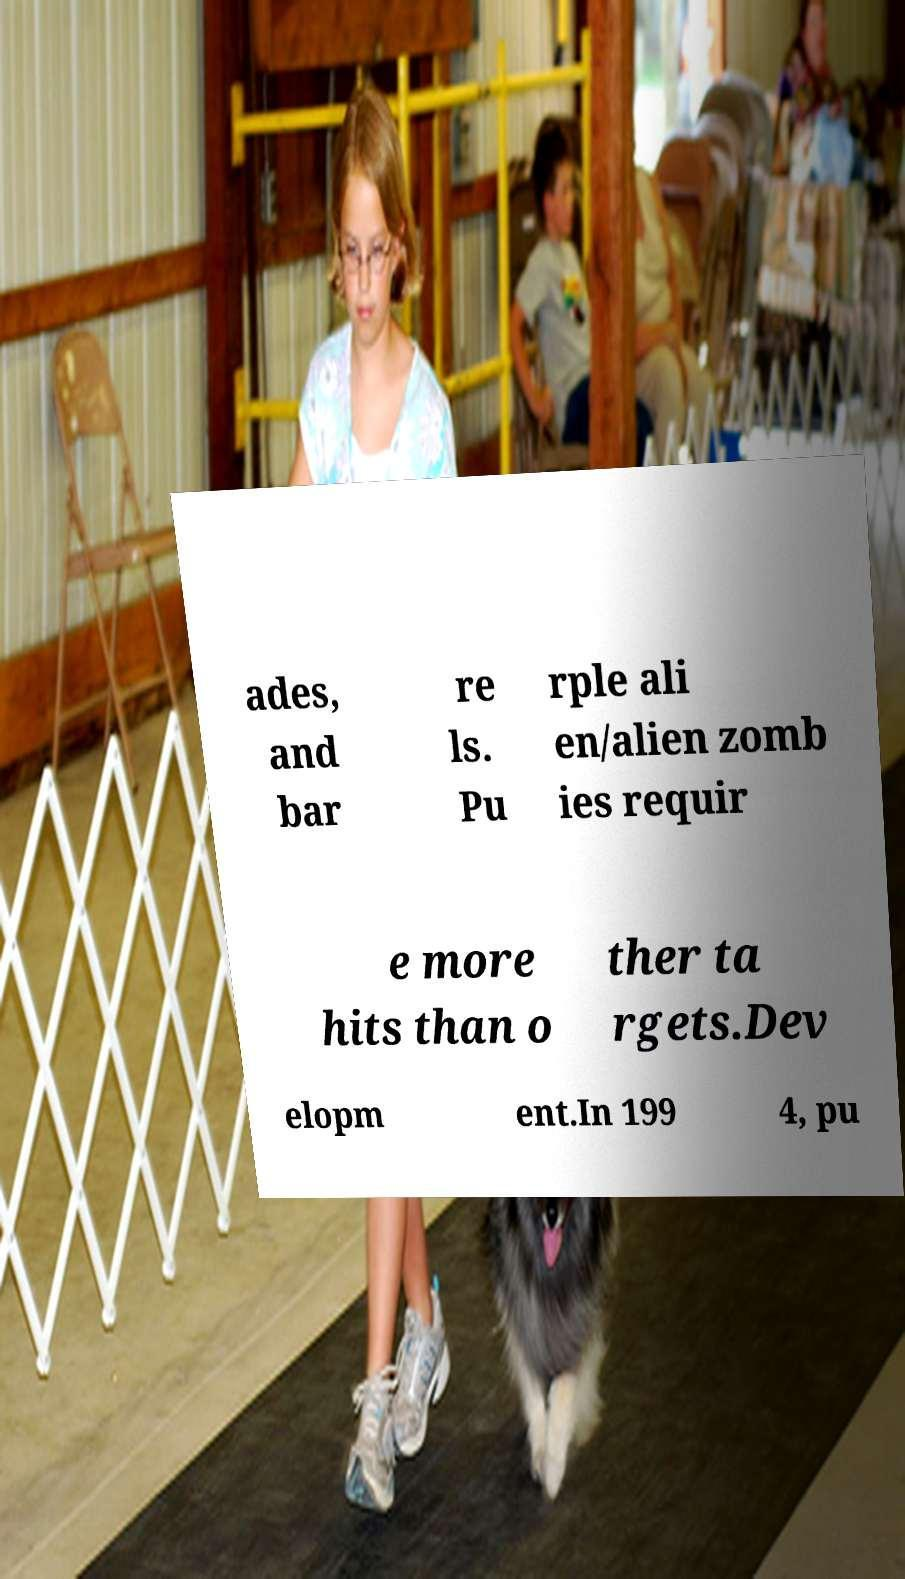Please identify and transcribe the text found in this image. ades, and bar re ls. Pu rple ali en/alien zomb ies requir e more hits than o ther ta rgets.Dev elopm ent.In 199 4, pu 